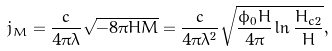<formula> <loc_0><loc_0><loc_500><loc_500>j _ { M } = \frac { c } { 4 \pi \lambda } \sqrt { - 8 \pi H M } = \frac { c } { 4 \pi \lambda ^ { 2 } } \sqrt { \frac { \phi _ { 0 } H } { 4 \pi } \ln \frac { H _ { c 2 } } { H } } ,</formula> 